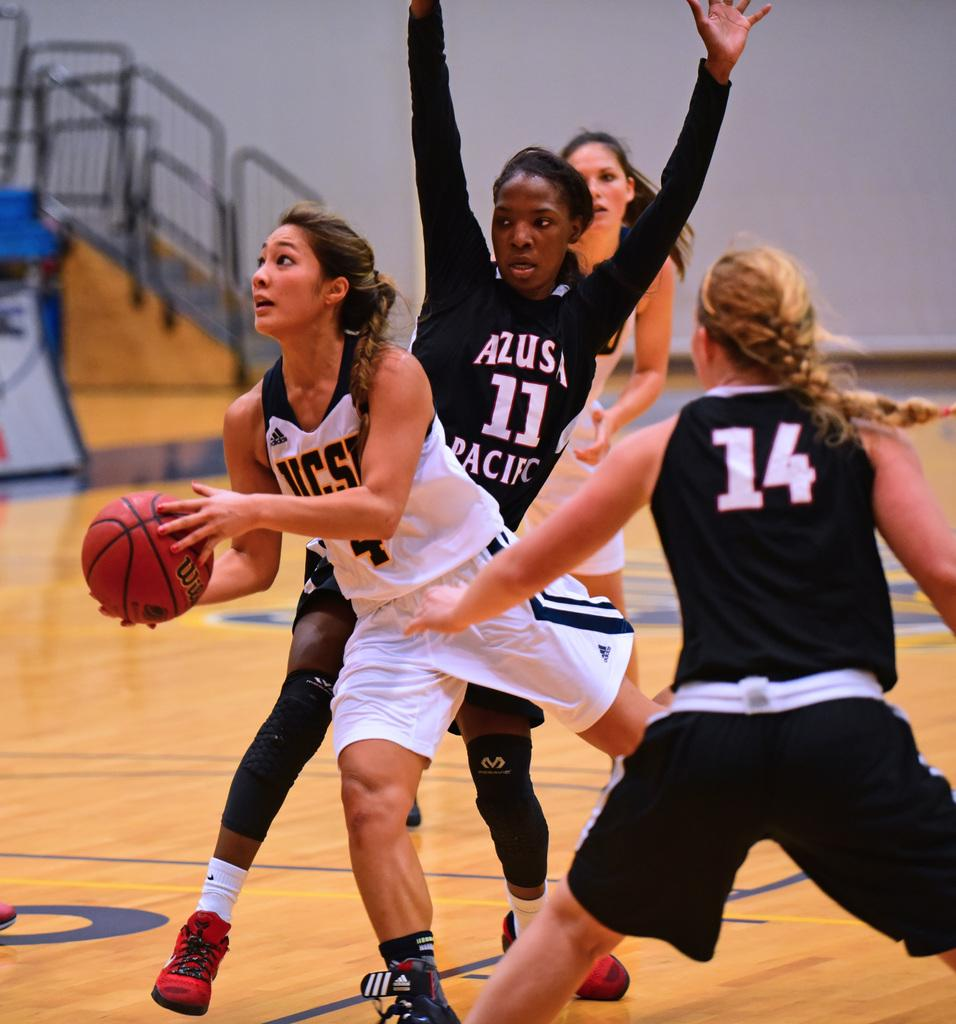<image>
Provide a brief description of the given image. A UCSD basketball player who wears number 4 slips past number 11 for Azusa Pacific to attempt a layup. 